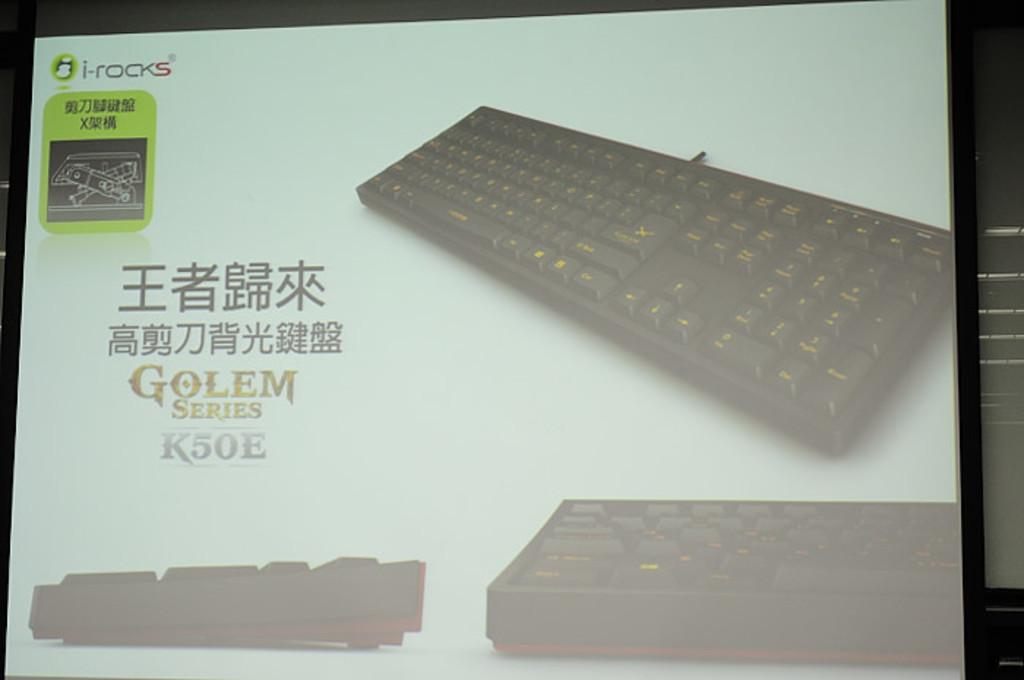Provide a one-sentence caption for the provided image. A black keyboard with orange letters in the Golem series. 